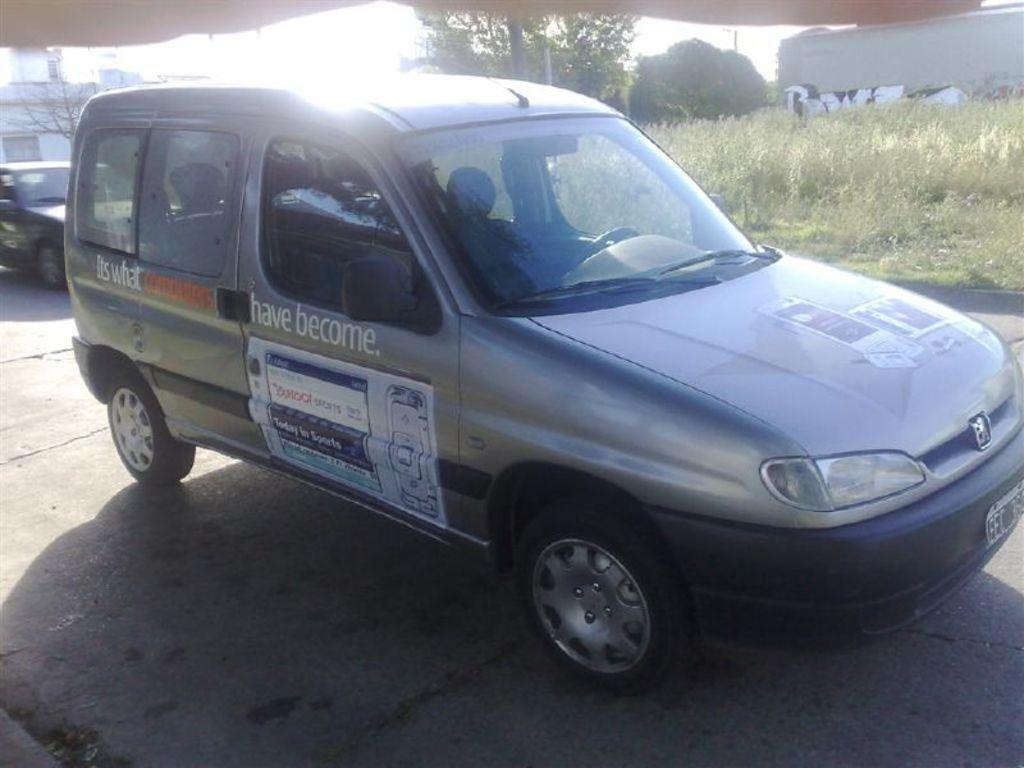<image>
Write a terse but informative summary of the picture. A grey van is parked in a driveway with the words have become on the side. 